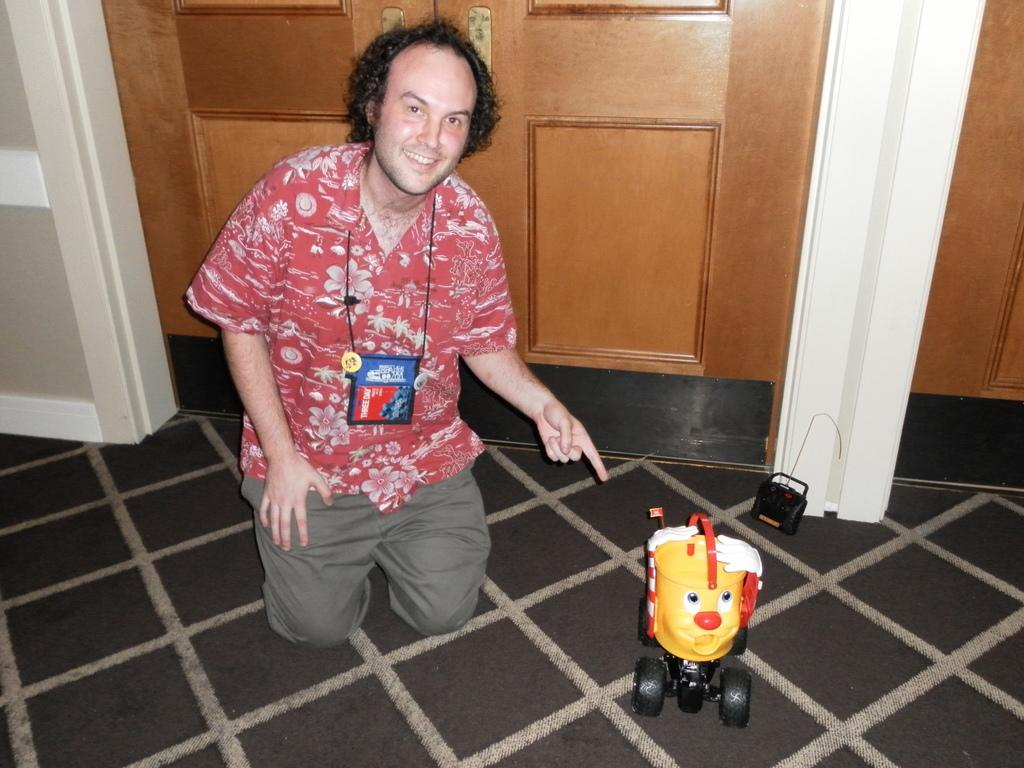What is the main subject in the foreground of the picture? There is a remote control toy in the foreground of the picture. Who or what else is in the foreground of the picture? There is a person in the foreground of the picture. What architectural feature can be seen in the image? There is a door visible in the image. What is located on the left side of the image? There is a pillar on the left side of the image. How many spoons are visible in the image? There are no spoons present in the image. What type of shoes is the person wearing in the image? There is no information about the person's shoes in the image. 